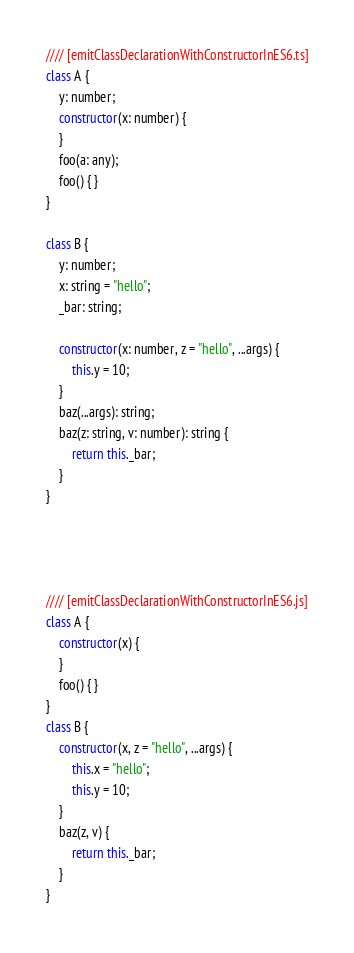Convert code to text. <code><loc_0><loc_0><loc_500><loc_500><_JavaScript_>//// [emitClassDeclarationWithConstructorInES6.ts]
class A {
    y: number;
    constructor(x: number) {
    }
    foo(a: any);
    foo() { }
}

class B {
    y: number;
    x: string = "hello";
    _bar: string;

    constructor(x: number, z = "hello", ...args) {
        this.y = 10;
    }
    baz(...args): string;
    baz(z: string, v: number): string {
        return this._bar;
    } 
}




//// [emitClassDeclarationWithConstructorInES6.js]
class A {
    constructor(x) {
    }
    foo() { }
}
class B {
    constructor(x, z = "hello", ...args) {
        this.x = "hello";
        this.y = 10;
    }
    baz(z, v) {
        return this._bar;
    }
}
</code> 